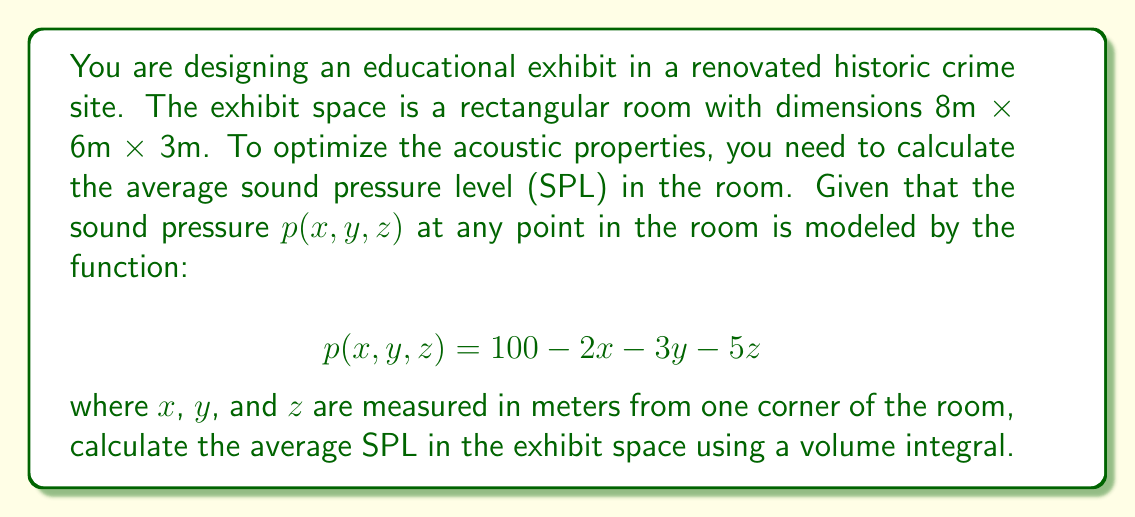Show me your answer to this math problem. To solve this problem, we need to follow these steps:

1) The average SPL is given by the volume integral of the pressure function divided by the total volume of the room.

2) Set up the triple integral for the volume:
   $$\text{Average SPL} = \frac{1}{V} \iiint_V p(x,y,z) \, dV$$
   where $V$ is the volume of the room.

3) Calculate the volume of the room:
   $V = 8 \times 6 \times 3 = 144$ m³

4) Set up the limits of integration:
   $x$ from 0 to 8, $y$ from 0 to 6, and $z$ from 0 to 3

5) Expand the integral:
   $$\text{Average SPL} = \frac{1}{144} \int_0^3 \int_0^6 \int_0^8 (100 - 2x - 3y - 5z) \, dx \, dy \, dz$$

6) Solve the triple integral:
   
   First, integrate with respect to x:
   $$\frac{1}{144} \int_0^3 \int_0^6 [100x - x^2 - 3xy - 5xz]_0^8 \, dy \, dz$$
   $$= \frac{1}{144} \int_0^3 \int_0^6 (800 - 64 - 24y - 40z) \, dy \, dz$$
   
   Then, integrate with respect to y:
   $$\frac{1}{144} \int_0^3 [(800 - 64)y - 12y^2 - 40yz]_0^6 \, dz$$
   $$= \frac{1}{144} \int_0^3 (4416 - 432 - 240z) \, dz$$
   
   Finally, integrate with respect to z:
   $$\frac{1}{144} [4416z - 432z - 120z^2]_0^3$$
   $$= \frac{1}{144} (13248 - 1296 - 1080)$$
   $$= \frac{10872}{144} = 75.5$$

7) Therefore, the average SPL in the room is 75.5 dB.
Answer: 75.5 dB 